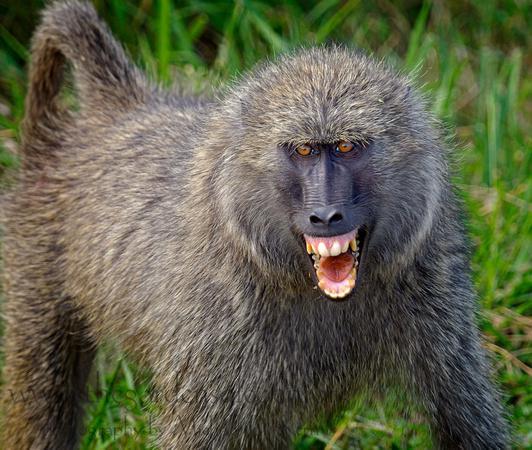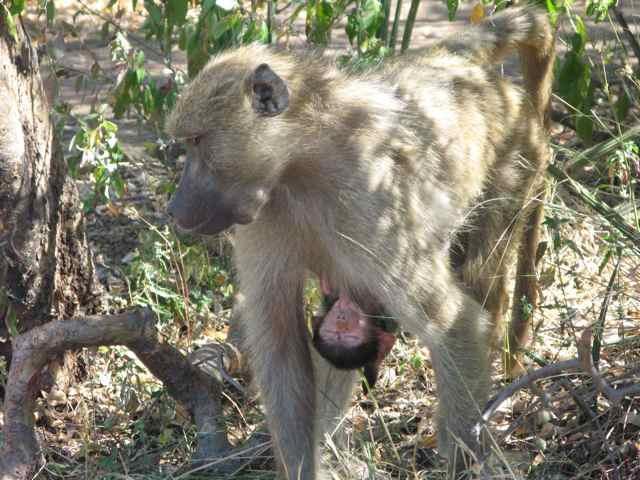The first image is the image on the left, the second image is the image on the right. Assess this claim about the two images: "There are at least two monkeys in the image on the right.". Correct or not? Answer yes or no. Yes. The first image is the image on the left, the second image is the image on the right. Examine the images to the left and right. Is the description "An image shows exactly one baboon, which is walking on all fours on the ground." accurate? Answer yes or no. Yes. 